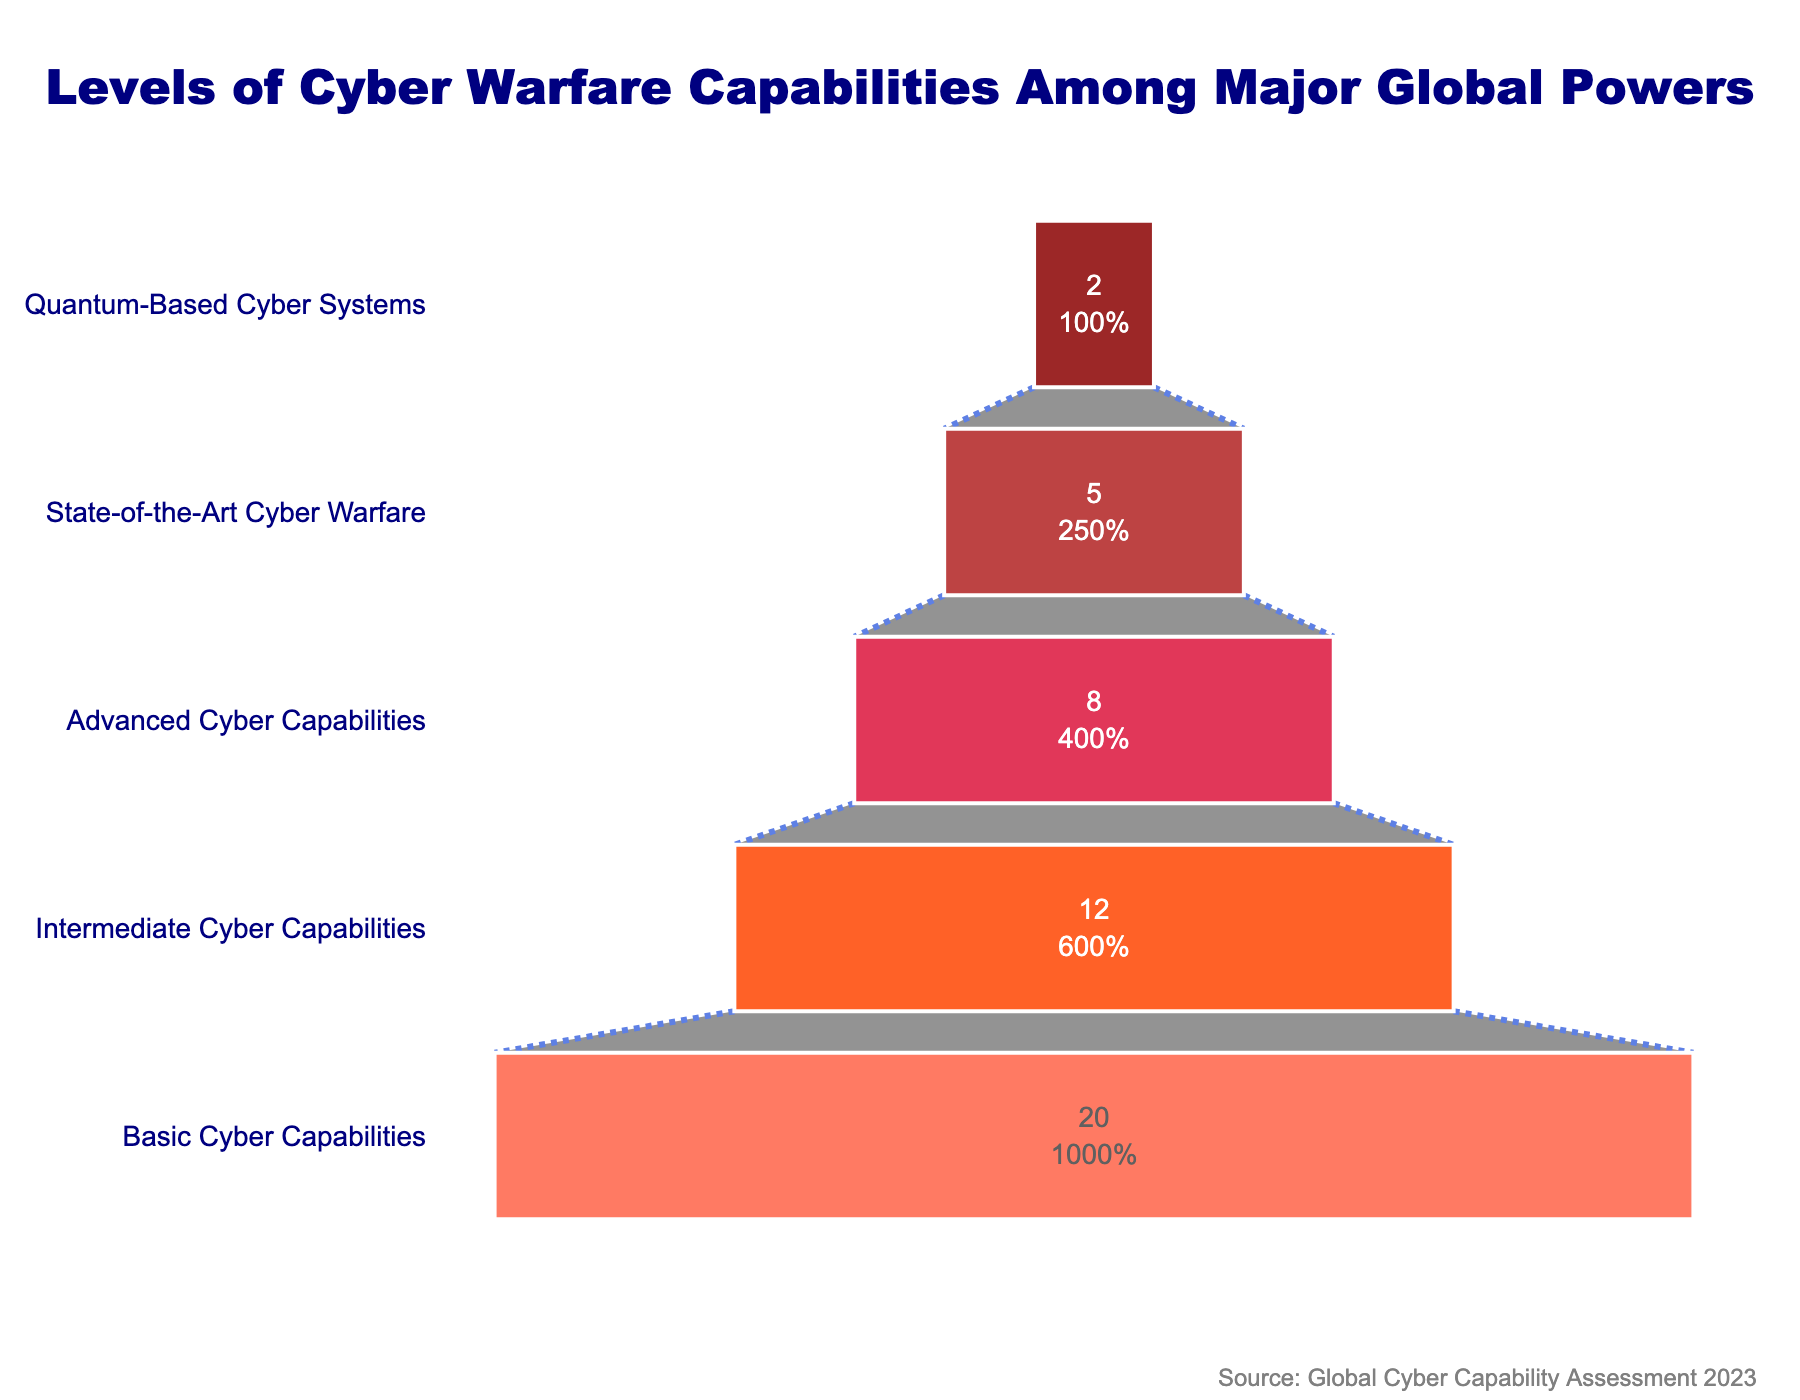How many countries have quantum-based cyber systems? The last segment of the funnel chart (at the bottom) represents countries with quantum-based cyber systems. According to the figure, this segment is labeled with the number of countries.
Answer: 2 What is the title of the funnel chart? The title is prominently displayed at the top center of the funnel chart.
Answer: Levels of Cyber Warfare Capabilities Among Major Global Powers Which category has the most countries? The largest segment of the funnel chart, which is at the top, represents the category with the most countries. This segment is labeled 'Basic Cyber Capabilities'.
Answer: Basic Cyber Capabilities What percentage of the total number of countries have advanced cyber capabilities? The advanced cyber capabilities segment shows both the number and percentage. To find the percentage, divide the number of countries with advanced capabilities by the total number of countries and multiply by 100. According to the chart, this information is directly provided.
Answer: 20% Compare the number of countries with state-of-the-art cyber warfare capabilities to those with quantum-based cyber systems. The funnel chart shows 5 countries with state-of-the-art capabilities and 2 countries with quantum-based systems. Comparing these numbers directly confirms that there are more countries with state-of-the-art capabilities.
Answer: State-of-the-Art has more What are the color differences among the segments of the funnel chart? Each segment of the funnel chart is shaded in a different color, ranging from deep red at the top to lighter shades of red towards the bottom.
Answer: Varies from dark red to light red How do the number of countries with intermediate capabilities compare to those with basic capabilities? The funnel chart shows 20 countries with basic capabilities and 12 with intermediate capabilities. Subtracting these, we get the difference.
Answer: Basic is 8 more than Intermediate If a country advances from basic to intermediate cyber capabilities, what is the new total for each category? Subtract 1 from the basic category and add 1 to the intermediate category. From the given data, this would change the number from 20 basic and 12 intermediate to 19 basic and 13 intermediate.
Answer: 19 basic, 13 intermediate How many total countries are represented in the chart? Sum all the countries in each category together. That is, 20 (Basic) + 12 (Intermediate) + 8 (Advanced) + 5 (State-of-the-Art) + 2 (Quantum-Based).
Answer: 47 